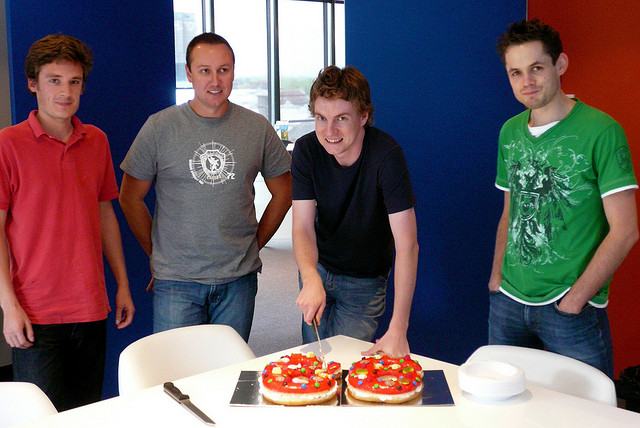<image>What color is the flower in her hair? There is no flower in her hair in the image. What color is the flower in her hair? There is no flower in her hair. 